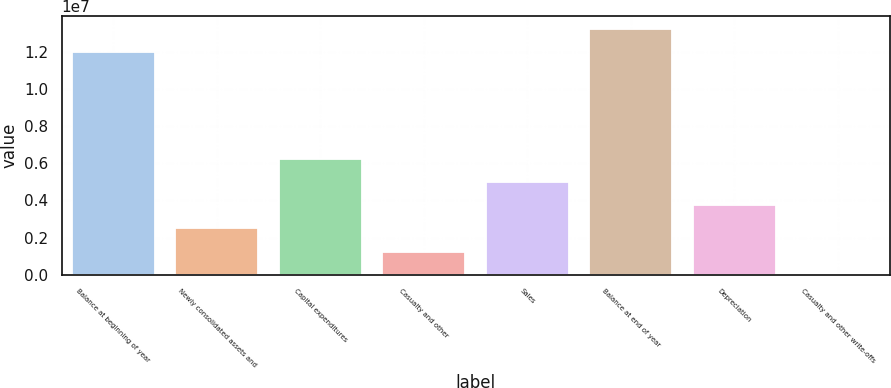Convert chart. <chart><loc_0><loc_0><loc_500><loc_500><bar_chart><fcel>Balance at beginning of year<fcel>Newly consolidated assets and<fcel>Capital expenditures<fcel>Casualty and other<fcel>Sales<fcel>Balance at end of year<fcel>Depreciation<fcel>Casualty and other write-offs<nl><fcel>1.20117e+07<fcel>2.48826e+06<fcel>6.21274e+06<fcel>1.24677e+06<fcel>4.97125e+06<fcel>1.32532e+07<fcel>3.72976e+06<fcel>5280<nl></chart> 